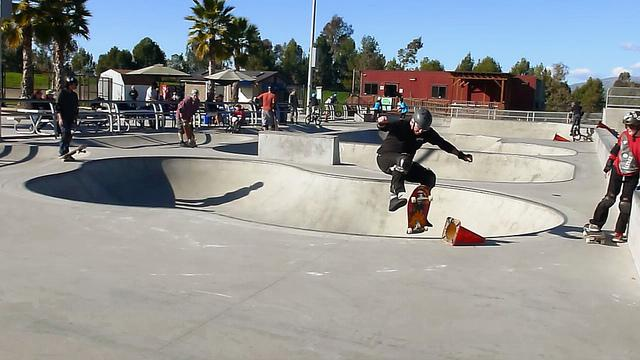Why have the skaters covered their heads? protection 